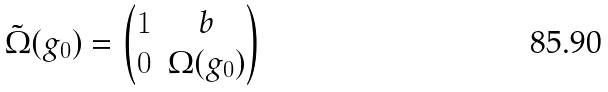Convert formula to latex. <formula><loc_0><loc_0><loc_500><loc_500>\tilde { \Omega } ( g _ { 0 } ) = \begin{pmatrix} 1 & b \\ 0 & \Omega ( g _ { 0 } ) \end{pmatrix}</formula> 